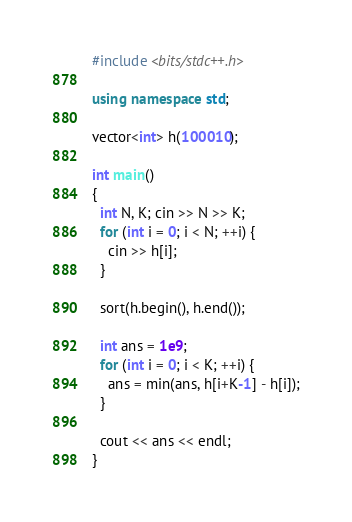<code> <loc_0><loc_0><loc_500><loc_500><_C++_>#include <bits/stdc++.h>

using namespace std;

vector<int> h(100010);

int main()
{
  int N, K; cin >> N >> K;
  for (int i = 0; i < N; ++i) {
    cin >> h[i];
  }

  sort(h.begin(), h.end());

  int ans = 1e9;
  for (int i = 0; i < K; ++i) {
    ans = min(ans, h[i+K-1] - h[i]);
  }

  cout << ans << endl;
}</code> 